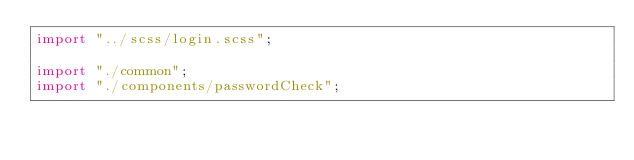Convert code to text. <code><loc_0><loc_0><loc_500><loc_500><_JavaScript_>import "../scss/login.scss";

import "./common";
import "./components/passwordCheck";

</code> 